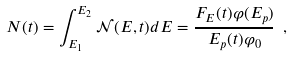Convert formula to latex. <formula><loc_0><loc_0><loc_500><loc_500>N ( t ) = \int _ { E _ { 1 } } ^ { E _ { 2 } } \mathcal { N } ( E , t ) d E = \frac { F _ { E } ( t ) \varphi ( E _ { p } ) } { E _ { p } ( t ) \varphi _ { 0 } } \ ,</formula> 